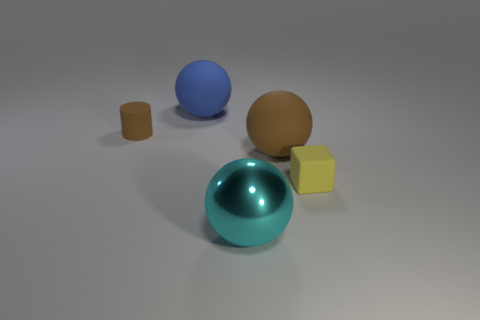Which object looks the heaviest and why? The spherical object in the center, with its larger size and high-gloss finish, gives the impression of being the heaviest. Objects with a shiny metallic finish often suggest a greater density than objects with a matte finish, potentially indicative of a heavier material. 